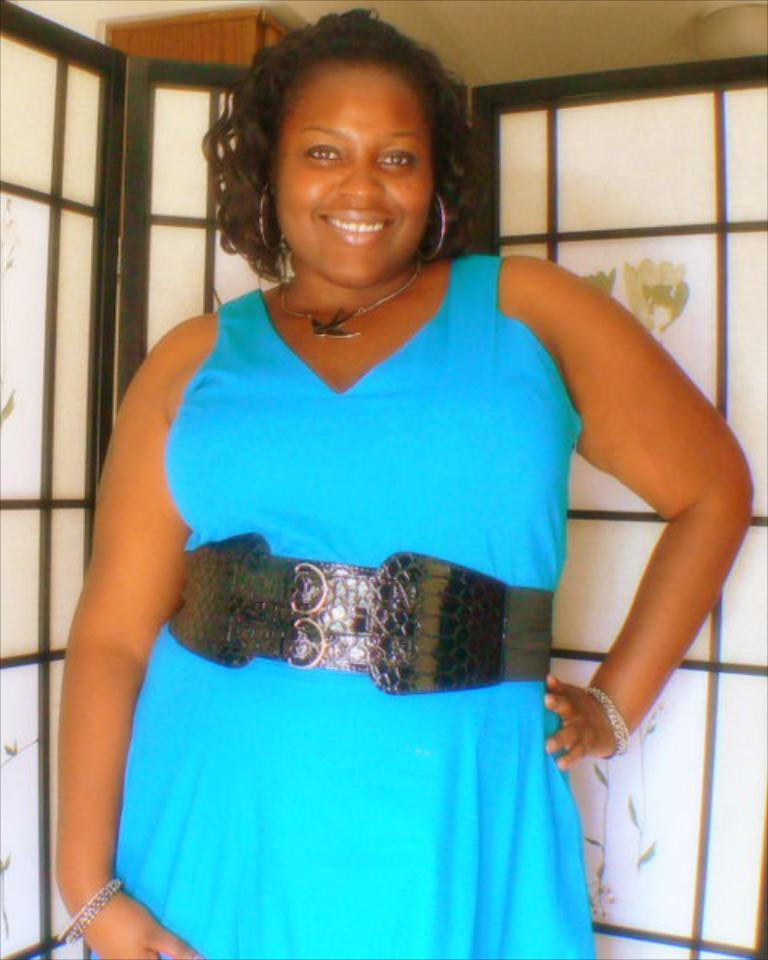Who is present in the image? There is a woman in the image. What is the woman wearing? The woman is wearing a blue dress. What can be seen in the background of the image? There is a glass door and a pillar in the background of the image. What part of the building is visible in the image? The roof is visible at the top of the image. What type of grain is growing in the garden behind the woman in the image? There is no garden or grain present in the image; it features a woman in a blue dress with a glass door and pillar in the background. 